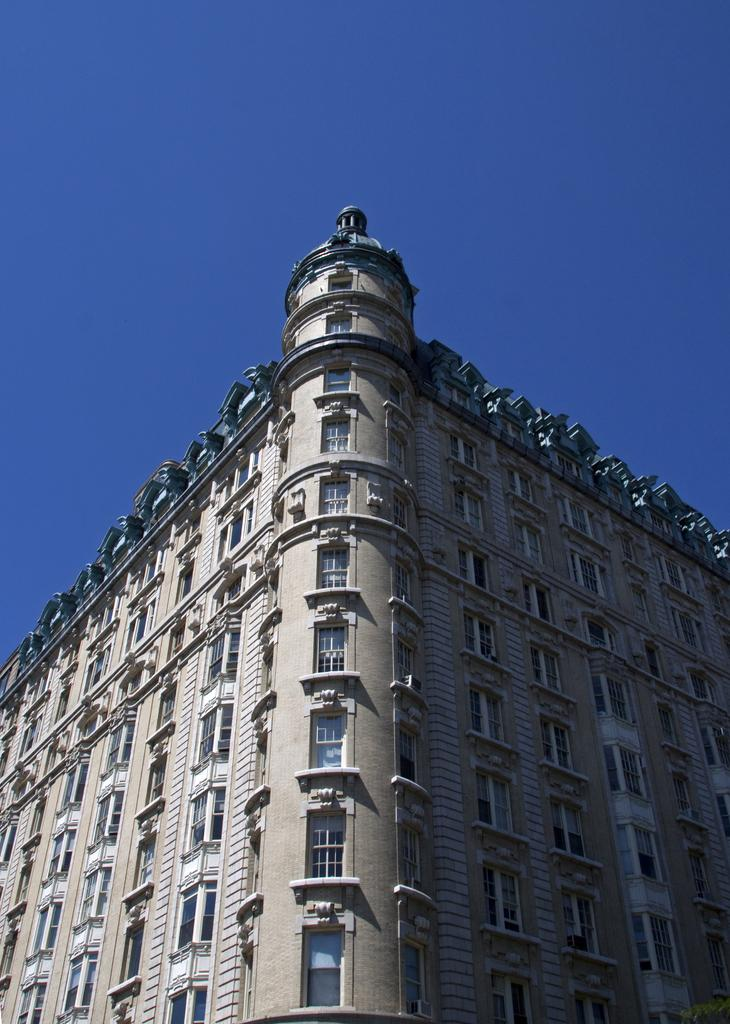What type of structure is present in the image? There is a building in the image. What type of insurance policy is being discussed at the desk in the image? There is no desk or insurance policy present in the image; it only features a building. 